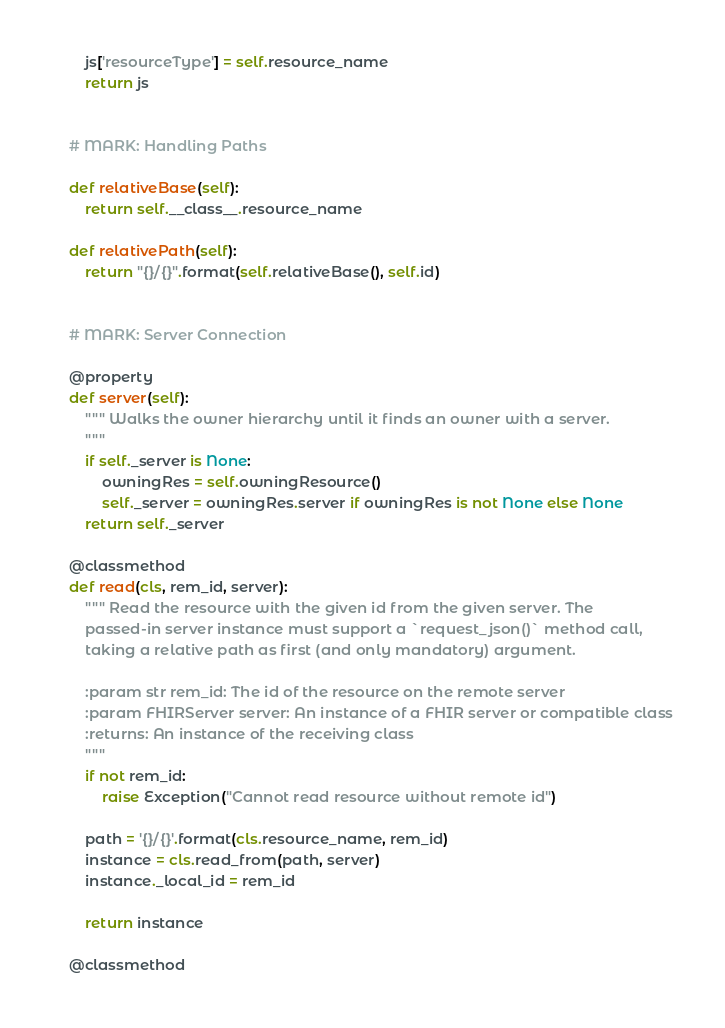Convert code to text. <code><loc_0><loc_0><loc_500><loc_500><_Python_>        js['resourceType'] = self.resource_name
        return js
    
    
    # MARK: Handling Paths
    
    def relativeBase(self):
        return self.__class__.resource_name
    
    def relativePath(self):
        return "{}/{}".format(self.relativeBase(), self.id)
    
    
    # MARK: Server Connection
    
    @property
    def server(self):
        """ Walks the owner hierarchy until it finds an owner with a server.
        """
        if self._server is None:
            owningRes = self.owningResource()
            self._server = owningRes.server if owningRes is not None else None
        return self._server
    
    @classmethod
    def read(cls, rem_id, server):
        """ Read the resource with the given id from the given server. The
        passed-in server instance must support a `request_json()` method call,
        taking a relative path as first (and only mandatory) argument.
        
        :param str rem_id: The id of the resource on the remote server
        :param FHIRServer server: An instance of a FHIR server or compatible class
        :returns: An instance of the receiving class
        """
        if not rem_id:
            raise Exception("Cannot read resource without remote id")
        
        path = '{}/{}'.format(cls.resource_name, rem_id)
        instance = cls.read_from(path, server)
        instance._local_id = rem_id
        
        return instance
    
    @classmethod</code> 